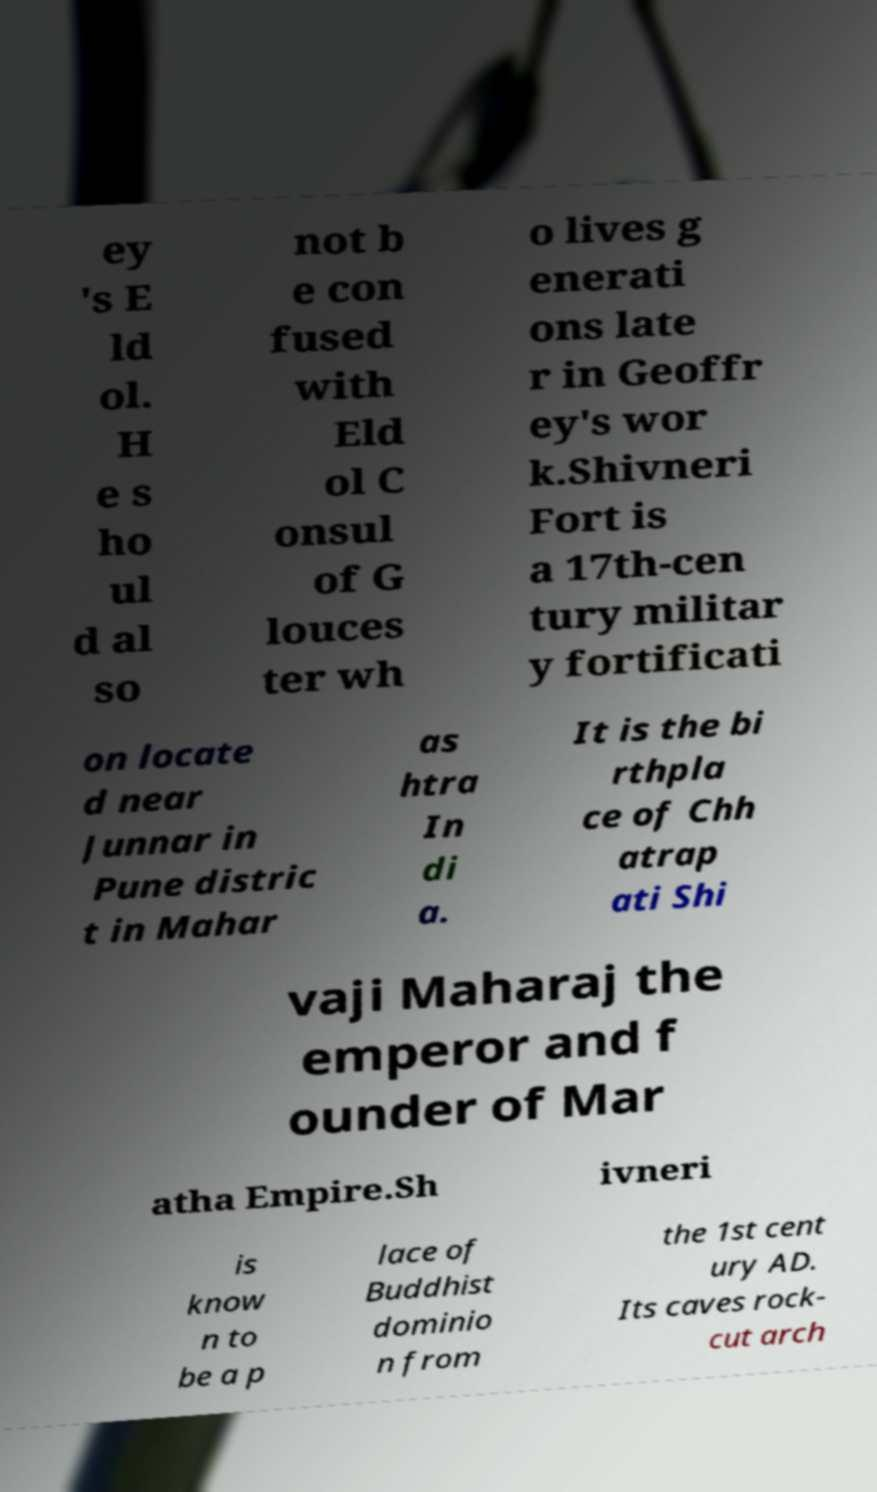For documentation purposes, I need the text within this image transcribed. Could you provide that? ey 's E ld ol. H e s ho ul d al so not b e con fused with Eld ol C onsul of G louces ter wh o lives g enerati ons late r in Geoffr ey's wor k.Shivneri Fort is a 17th-cen tury militar y fortificati on locate d near Junnar in Pune distric t in Mahar as htra In di a. It is the bi rthpla ce of Chh atrap ati Shi vaji Maharaj the emperor and f ounder of Mar atha Empire.Sh ivneri is know n to be a p lace of Buddhist dominio n from the 1st cent ury AD. Its caves rock- cut arch 